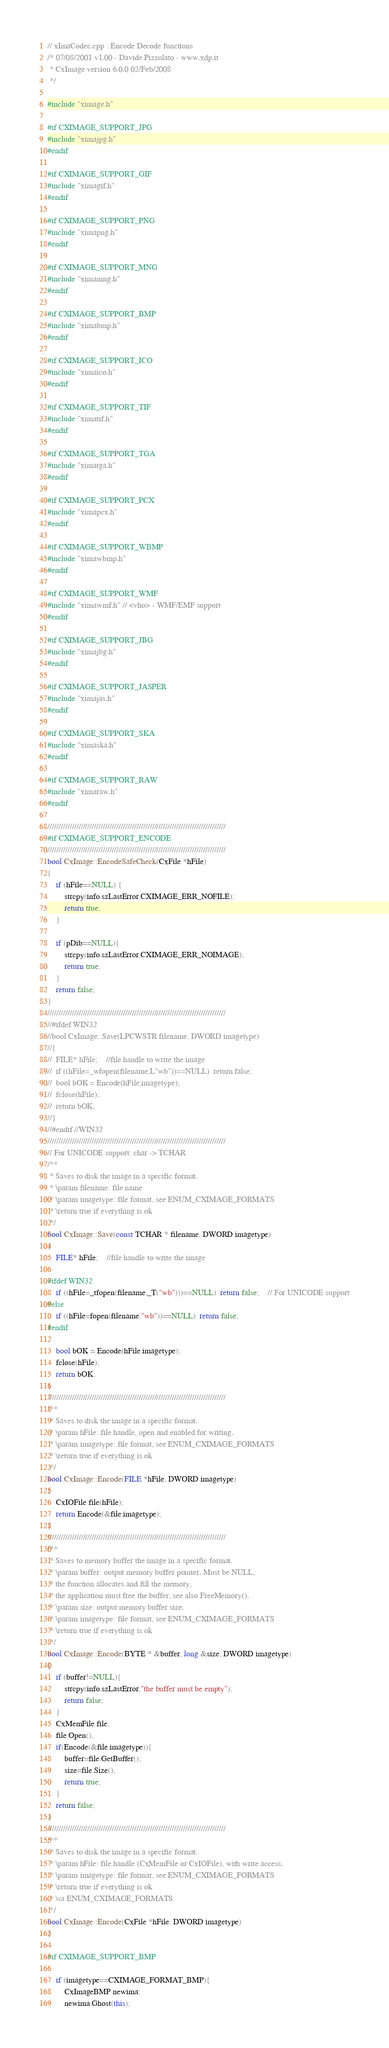<code> <loc_0><loc_0><loc_500><loc_500><_C++_>// xImaCodec.cpp : Encode Decode functions
/* 07/08/2001 v1.00 - Davide Pizzolato - www.xdp.it
 * CxImage version 6.0.0 02/Feb/2008
 */

#include "ximage.h"

#if CXIMAGE_SUPPORT_JPG
#include "ximajpg.h"
#endif

#if CXIMAGE_SUPPORT_GIF
#include "ximagif.h"
#endif

#if CXIMAGE_SUPPORT_PNG
#include "ximapng.h"
#endif

#if CXIMAGE_SUPPORT_MNG
#include "ximamng.h"
#endif

#if CXIMAGE_SUPPORT_BMP
#include "ximabmp.h"
#endif

#if CXIMAGE_SUPPORT_ICO
#include "ximaico.h"
#endif

#if CXIMAGE_SUPPORT_TIF
#include "ximatif.h"
#endif

#if CXIMAGE_SUPPORT_TGA
#include "ximatga.h"
#endif

#if CXIMAGE_SUPPORT_PCX
#include "ximapcx.h"
#endif

#if CXIMAGE_SUPPORT_WBMP
#include "ximawbmp.h"
#endif

#if CXIMAGE_SUPPORT_WMF
#include "ximawmf.h" // <vho> - WMF/EMF support
#endif

#if CXIMAGE_SUPPORT_JBG
#include "ximajbg.h"
#endif

#if CXIMAGE_SUPPORT_JASPER
#include "ximajas.h"
#endif

#if CXIMAGE_SUPPORT_SKA
#include "ximaska.h"
#endif

#if CXIMAGE_SUPPORT_RAW
#include "ximaraw.h"
#endif

////////////////////////////////////////////////////////////////////////////////
#if CXIMAGE_SUPPORT_ENCODE
////////////////////////////////////////////////////////////////////////////////
bool CxImage::EncodeSafeCheck(CxFile *hFile)
{
	if (hFile==NULL) {
		strcpy(info.szLastError,CXIMAGE_ERR_NOFILE);
		return true;
	}

	if (pDib==NULL){
		strcpy(info.szLastError,CXIMAGE_ERR_NOIMAGE);
		return true;
	}
	return false;
}
////////////////////////////////////////////////////////////////////////////////
//#ifdef WIN32
//bool CxImage::Save(LPCWSTR filename, DWORD imagetype)
//{
//	FILE* hFile;	//file handle to write the image
//	if ((hFile=_wfopen(filename,L"wb"))==NULL)  return false;
//	bool bOK = Encode(hFile,imagetype);
//	fclose(hFile);
//	return bOK;
//}
//#endif //WIN32
////////////////////////////////////////////////////////////////////////////////
// For UNICODE support: char -> TCHAR
/**
 * Saves to disk the image in a specific format.
 * \param filename: file name
 * \param imagetype: file format, see ENUM_CXIMAGE_FORMATS
 * \return true if everything is ok
 */
bool CxImage::Save(const TCHAR * filename, DWORD imagetype)
{
	FILE* hFile;	//file handle to write the image

#ifdef WIN32
	if ((hFile=_tfopen(filename,_T("wb")))==NULL)  return false;	// For UNICODE support
#else
	if ((hFile=fopen(filename,"wb"))==NULL)  return false;
#endif

	bool bOK = Encode(hFile,imagetype);
	fclose(hFile);
	return bOK;
}
////////////////////////////////////////////////////////////////////////////////
/**
 * Saves to disk the image in a specific format.
 * \param hFile: file handle, open and enabled for writing.
 * \param imagetype: file format, see ENUM_CXIMAGE_FORMATS
 * \return true if everything is ok
 */
bool CxImage::Encode(FILE *hFile, DWORD imagetype)
{
	CxIOFile file(hFile);
	return Encode(&file,imagetype);
}
////////////////////////////////////////////////////////////////////////////////
/**
 * Saves to memory buffer the image in a specific format.
 * \param buffer: output memory buffer pointer. Must be NULL,
 * the function allocates and fill the memory,
 * the application must free the buffer, see also FreeMemory().
 * \param size: output memory buffer size.
 * \param imagetype: file format, see ENUM_CXIMAGE_FORMATS
 * \return true if everything is ok
 */
bool CxImage::Encode(BYTE * &buffer, long &size, DWORD imagetype)
{
	if (buffer!=NULL){
		strcpy(info.szLastError,"the buffer must be empty");
		return false;
	}
	CxMemFile file;
	file.Open();
	if(Encode(&file,imagetype)){
		buffer=file.GetBuffer();
		size=file.Size();
		return true;
	}
	return false;
}
////////////////////////////////////////////////////////////////////////////////
/**
 * Saves to disk the image in a specific format.
 * \param hFile: file handle (CxMemFile or CxIOFile), with write access.
 * \param imagetype: file format, see ENUM_CXIMAGE_FORMATS
 * \return true if everything is ok
 * \sa ENUM_CXIMAGE_FORMATS
 */
bool CxImage::Encode(CxFile *hFile, DWORD imagetype)
{

#if CXIMAGE_SUPPORT_BMP

	if (imagetype==CXIMAGE_FORMAT_BMP){
		CxImageBMP newima;
		newima.Ghost(this);</code> 